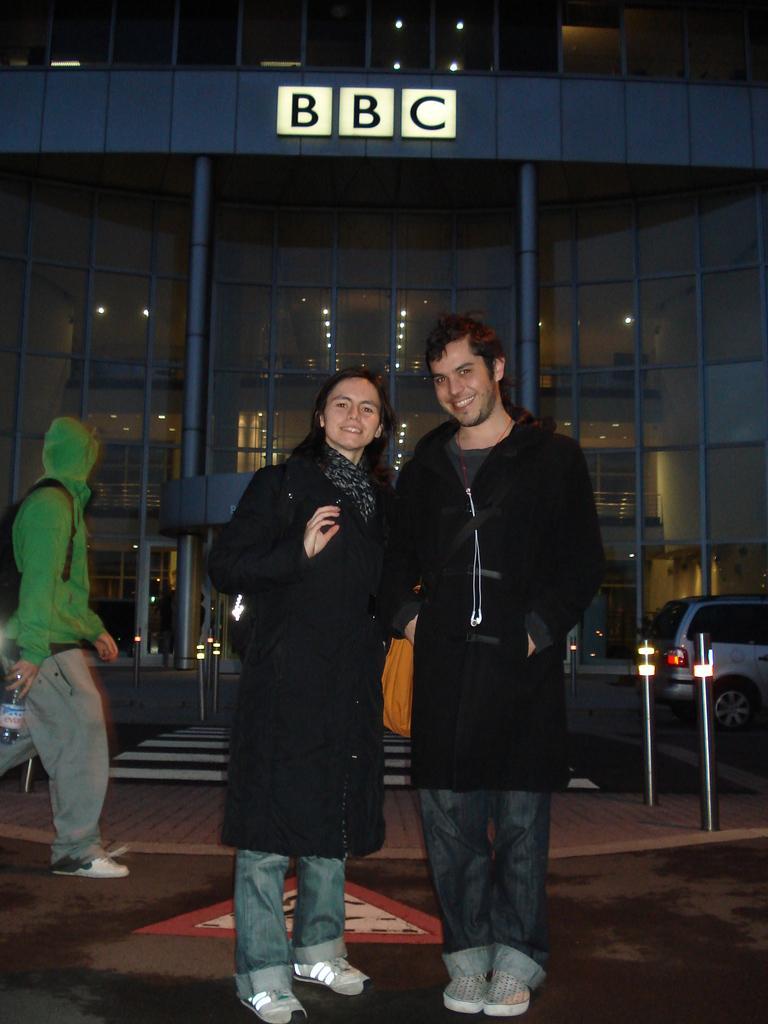How would you summarize this image in a sentence or two? Here in this picture we can see a couple standing on the road over there, both of them are wearing black colored coats and smiling and on the left side we can see a person walking over there with a green colored jacket on him and wearing a bag and holding a bottle in his hand and we can also see cars present on the road over there and behind them we can see a building present, with company's logo present on it over there. 